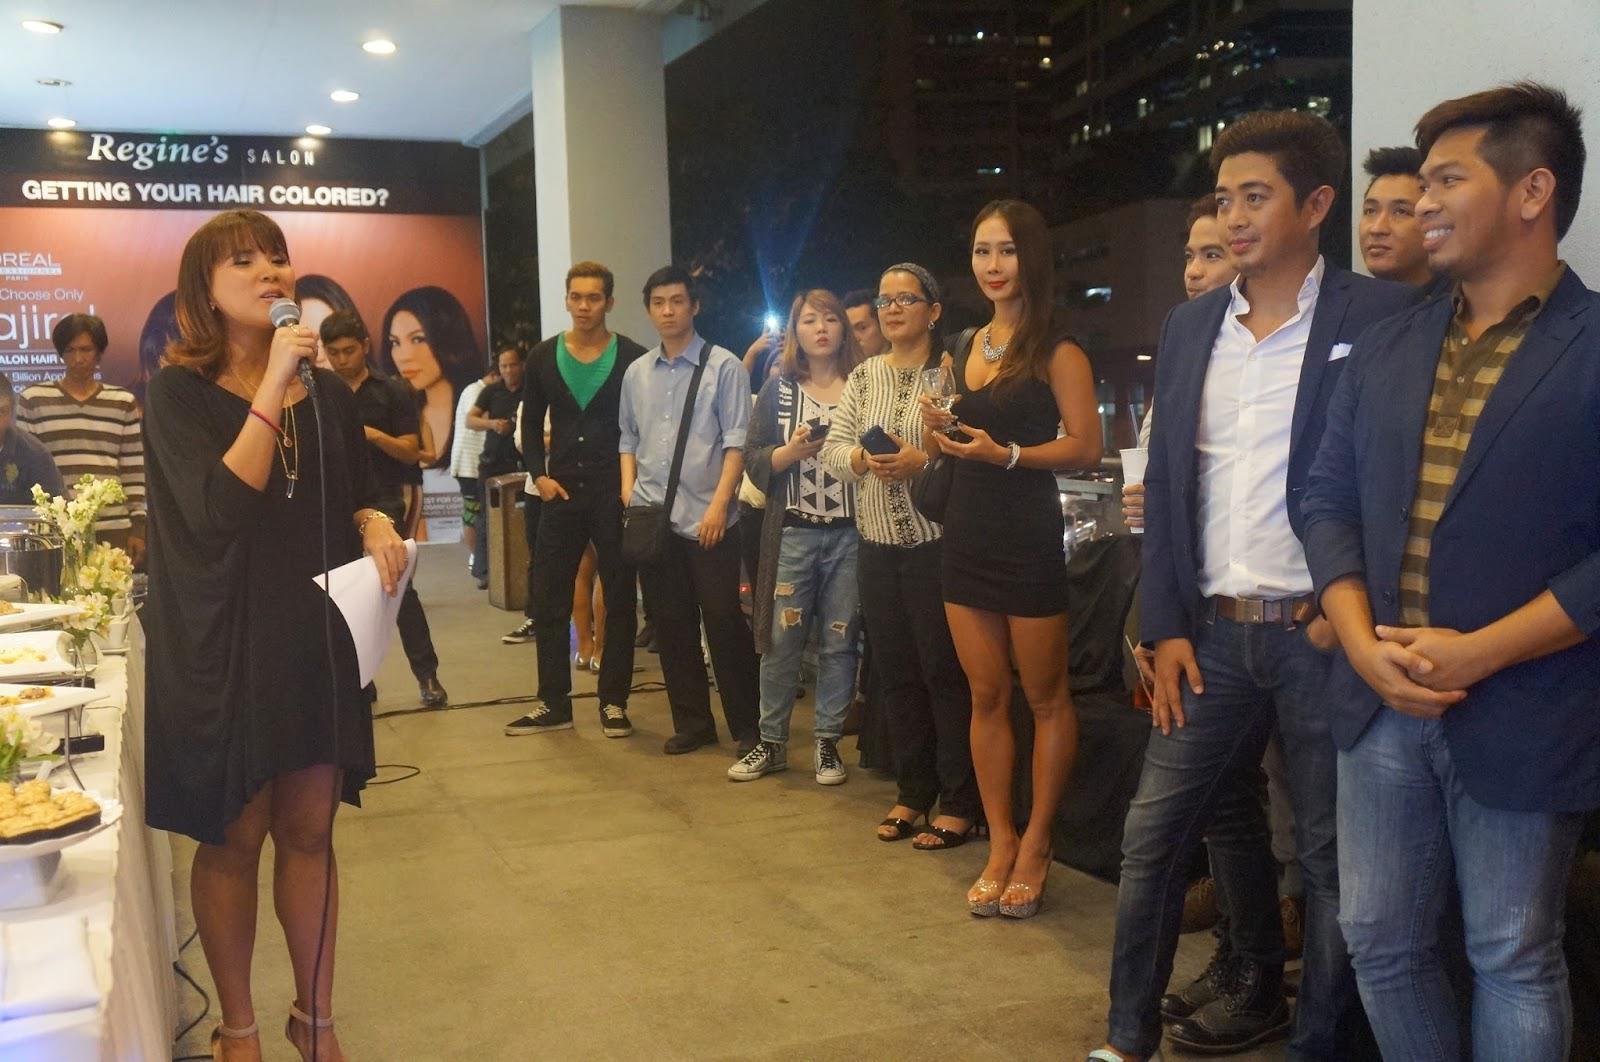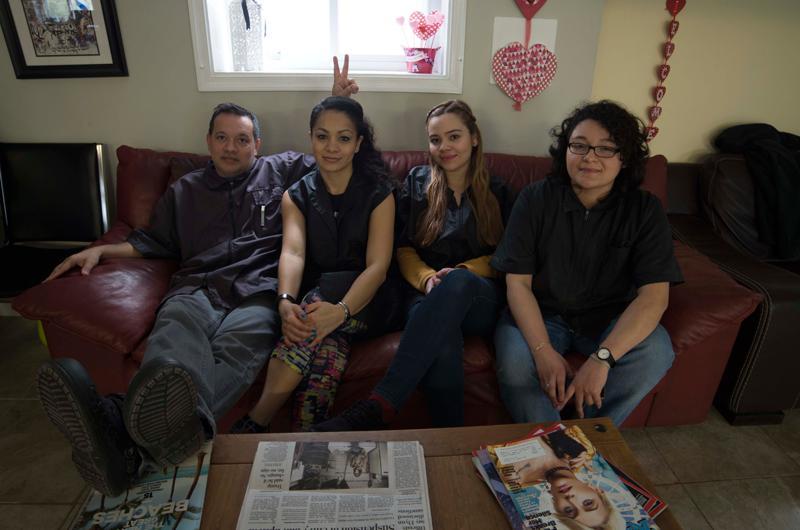The first image is the image on the left, the second image is the image on the right. Given the left and right images, does the statement "All the people are African Americans." hold true? Answer yes or no. No. 